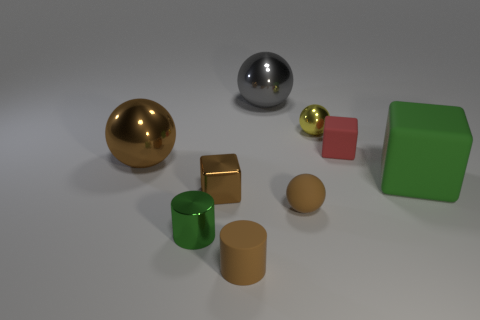Are there any other things that have the same size as the red rubber thing?
Provide a short and direct response. Yes. Do the metallic cube and the small rubber ball have the same color?
Provide a succinct answer. Yes. There is a metal ball that is the same color as the matte cylinder; what size is it?
Ensure brevity in your answer.  Large. What is the size of the rubber cube on the right side of the small rubber thing that is right of the small metallic object that is on the right side of the gray shiny thing?
Your response must be concise. Large. How big is the matte cube that is behind the large green matte object?
Provide a succinct answer. Small. There is a green object on the right side of the metallic block; what material is it?
Offer a terse response. Rubber. What number of cyan things are either rubber cubes or spheres?
Provide a succinct answer. 0. Does the small brown sphere have the same material as the large object that is left of the green cylinder?
Provide a succinct answer. No. Is the number of cubes that are on the left side of the brown cylinder the same as the number of large gray metal balls that are in front of the brown metal ball?
Make the answer very short. No. There is a brown matte ball; is it the same size as the block on the left side of the big gray thing?
Your answer should be very brief. Yes. 